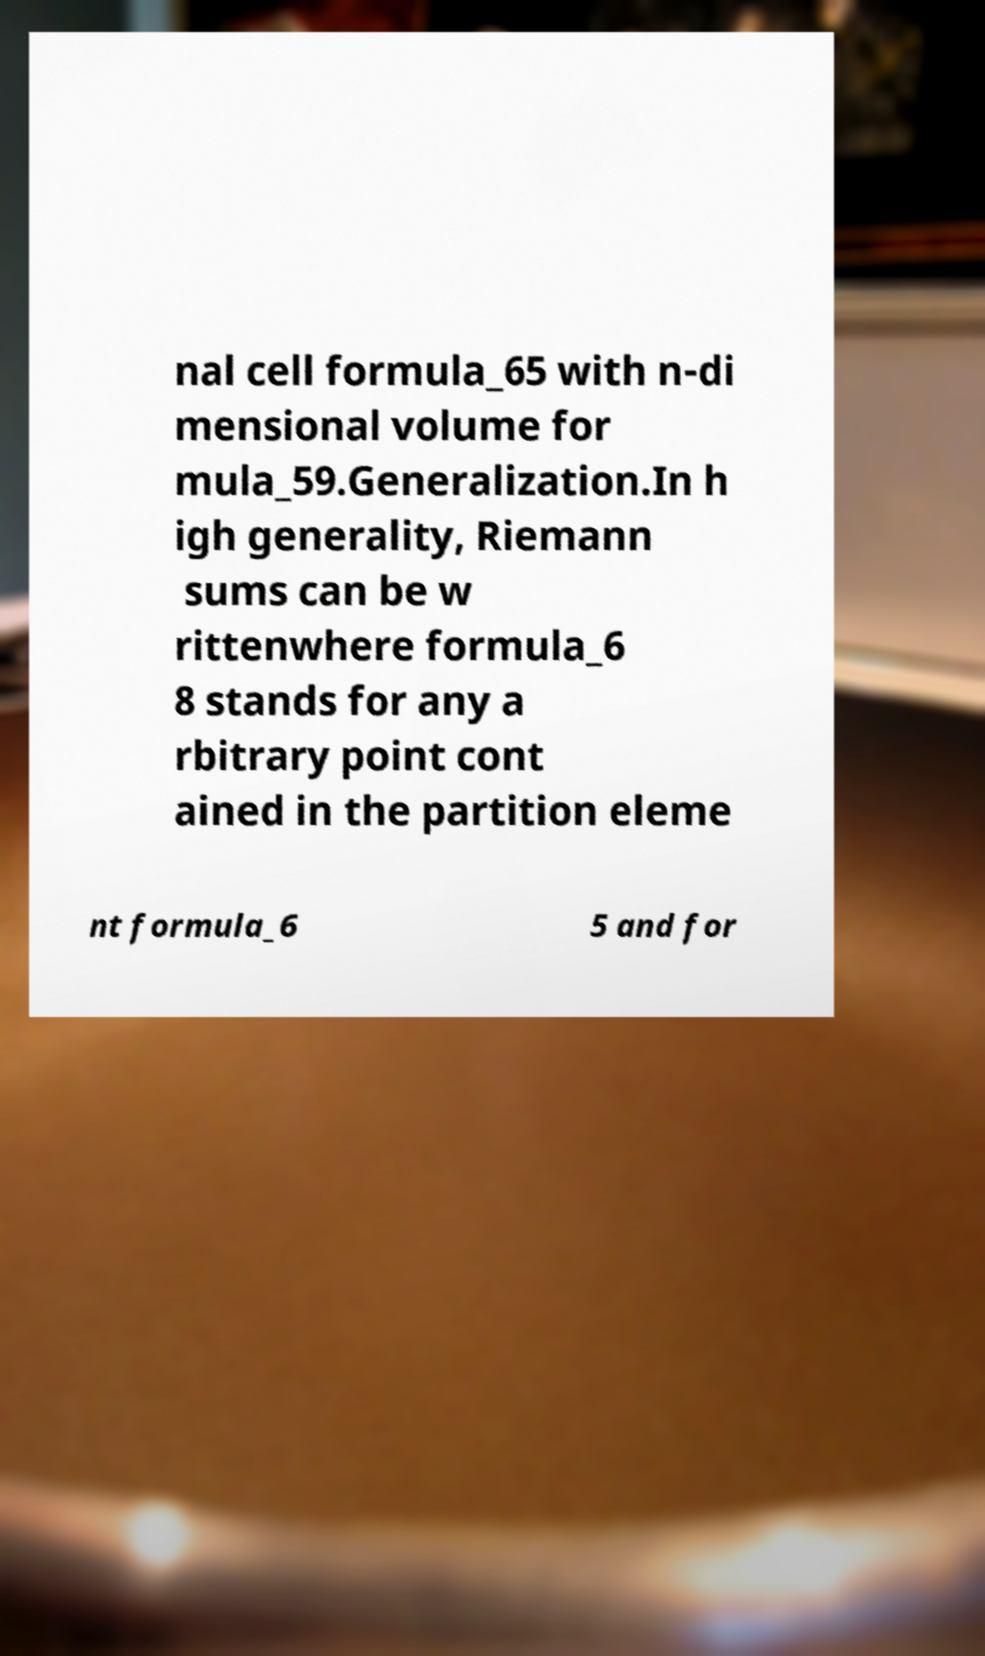Could you extract and type out the text from this image? nal cell formula_65 with n-di mensional volume for mula_59.Generalization.In h igh generality, Riemann sums can be w rittenwhere formula_6 8 stands for any a rbitrary point cont ained in the partition eleme nt formula_6 5 and for 